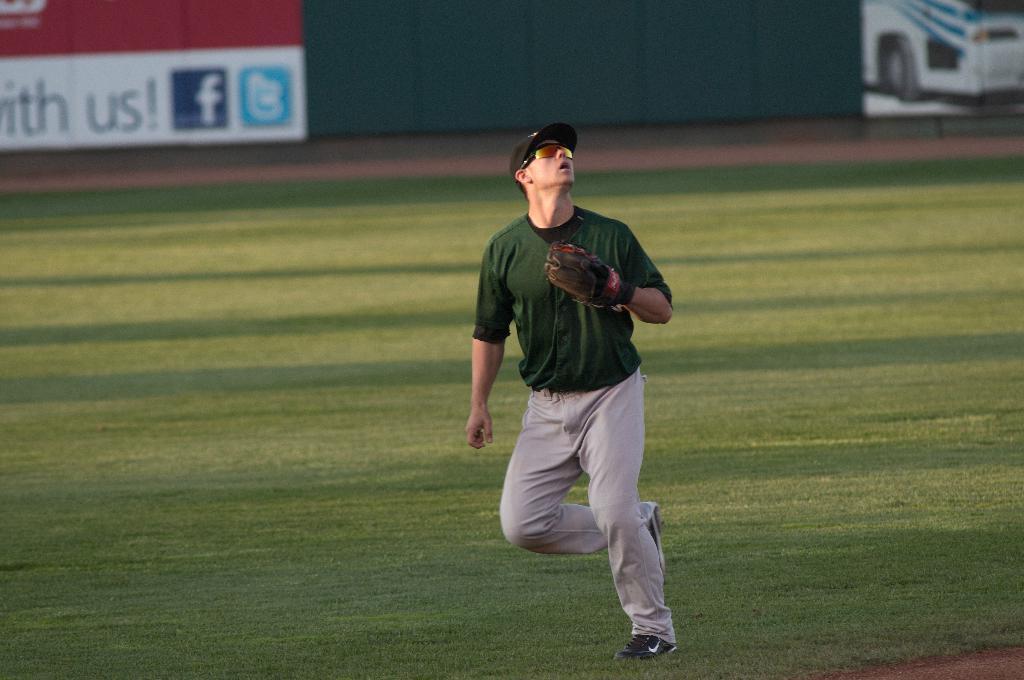The sign in the background is with who?
Your answer should be very brief. Us. Who is the sponsor on the board that starts with an 'f'?
Give a very brief answer. Facebook. 